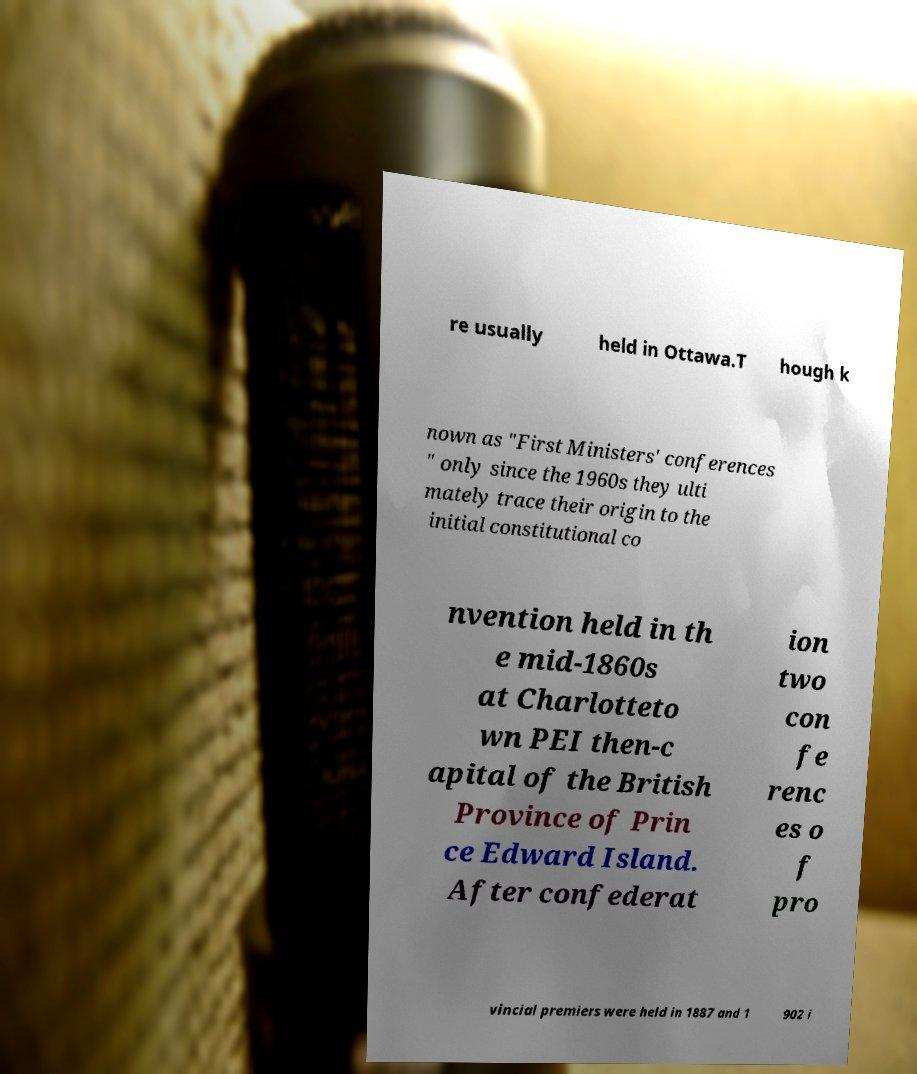Could you assist in decoding the text presented in this image and type it out clearly? re usually held in Ottawa.T hough k nown as "First Ministers' conferences " only since the 1960s they ulti mately trace their origin to the initial constitutional co nvention held in th e mid-1860s at Charlotteto wn PEI then-c apital of the British Province of Prin ce Edward Island. After confederat ion two con fe renc es o f pro vincial premiers were held in 1887 and 1 902 i 